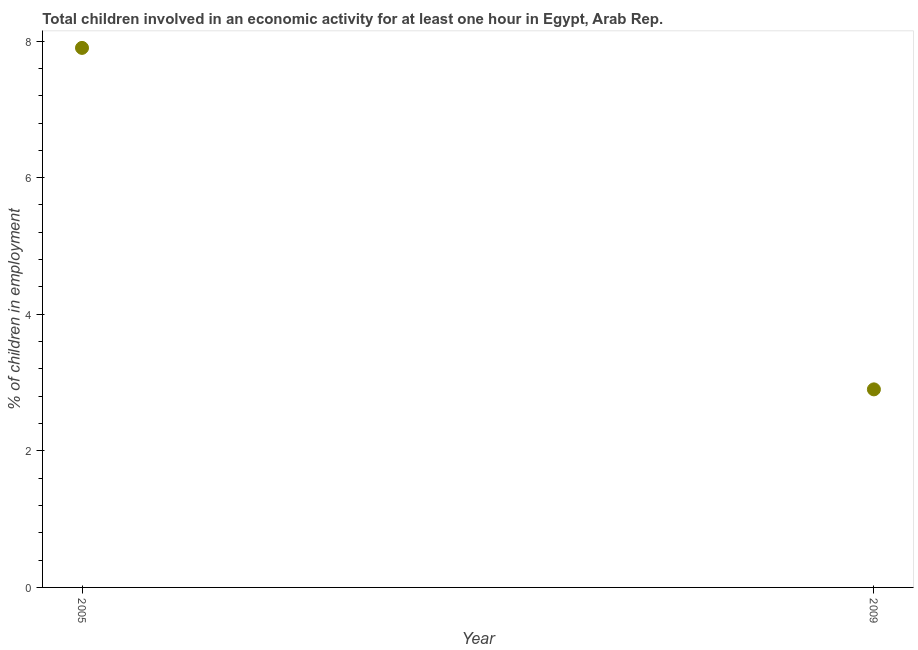What is the percentage of children in employment in 2005?
Keep it short and to the point. 7.9. What is the sum of the percentage of children in employment?
Give a very brief answer. 10.8. What is the average percentage of children in employment per year?
Provide a short and direct response. 5.4. What is the median percentage of children in employment?
Keep it short and to the point. 5.4. In how many years, is the percentage of children in employment greater than 4.8 %?
Your answer should be compact. 1. Do a majority of the years between 2009 and 2005 (inclusive) have percentage of children in employment greater than 1.6 %?
Your response must be concise. No. What is the ratio of the percentage of children in employment in 2005 to that in 2009?
Provide a succinct answer. 2.72. Is the percentage of children in employment in 2005 less than that in 2009?
Make the answer very short. No. Does the percentage of children in employment monotonically increase over the years?
Keep it short and to the point. No. How many dotlines are there?
Provide a short and direct response. 1. How many years are there in the graph?
Your response must be concise. 2. What is the difference between two consecutive major ticks on the Y-axis?
Provide a succinct answer. 2. Are the values on the major ticks of Y-axis written in scientific E-notation?
Make the answer very short. No. Does the graph contain any zero values?
Offer a terse response. No. What is the title of the graph?
Your response must be concise. Total children involved in an economic activity for at least one hour in Egypt, Arab Rep. What is the label or title of the X-axis?
Your answer should be compact. Year. What is the label or title of the Y-axis?
Ensure brevity in your answer.  % of children in employment. What is the ratio of the % of children in employment in 2005 to that in 2009?
Make the answer very short. 2.72. 